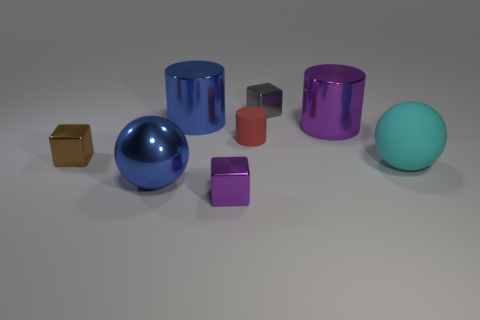Add 1 small red matte cylinders. How many objects exist? 9 Subtract all cubes. How many objects are left? 5 Add 2 matte spheres. How many matte spheres are left? 3 Add 8 brown cubes. How many brown cubes exist? 9 Subtract 0 blue cubes. How many objects are left? 8 Subtract all metallic spheres. Subtract all tiny brown blocks. How many objects are left? 6 